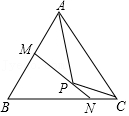Summarize the features presented in the diagram. The diagram illustrates a triangle ABC with vertices A, B, and C. Inside this triangle, there exists a point P, and a line segment MN passes through P, creating intersections at M on AB and N on BC. Notably, point M aligns with the perpendicular bisector of AP, suggesting it is equidistant from points A and P. Similarly, point N is positioned on the perpendicular bisector of CP, indicating its equal distance from points C and P. These features possibly indicate a deeper geometrical relationship or theorem at play, perhaps relating to the circles or other geometric properties. 